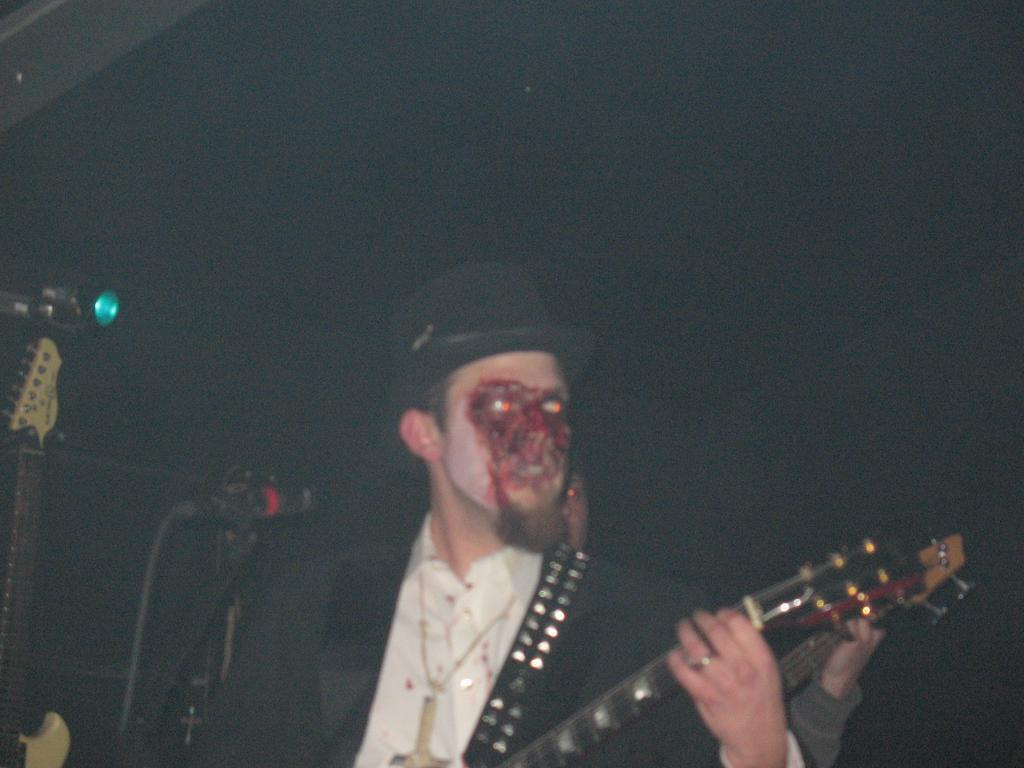What is the man in the image holding? The man is holding a musical instrument. Can you describe the man's appearance in the image? The man has a blood stain on his face and is wearing a black cap. What type of ship can be seen in the background of the image? There is no ship present in the image. What is the purpose of the alarm that is ringing in the image? There is no alarm ringing in the image. 